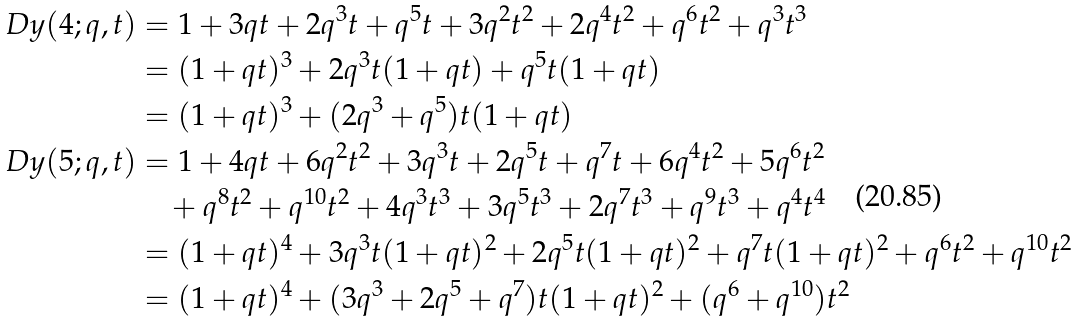<formula> <loc_0><loc_0><loc_500><loc_500>\ D y ( 4 ; q , t ) & = 1 + 3 q t + 2 q ^ { 3 } t + q ^ { 5 } t + 3 q ^ { 2 } t ^ { 2 } + 2 q ^ { 4 } t ^ { 2 } + q ^ { 6 } t ^ { 2 } + q ^ { 3 } t ^ { 3 } \\ & = ( 1 + q t ) ^ { 3 } + 2 q ^ { 3 } t ( 1 + q t ) + q ^ { 5 } t ( 1 + q t ) \\ & = ( 1 + q t ) ^ { 3 } + ( 2 q ^ { 3 } + q ^ { 5 } ) t ( 1 + q t ) \\ \ D y ( 5 ; q , t ) & = 1 + 4 q t + 6 q ^ { 2 } t ^ { 2 } + 3 q ^ { 3 } t + 2 q ^ { 5 } t + q ^ { 7 } t + 6 q ^ { 4 } t ^ { 2 } + 5 q ^ { 6 } t ^ { 2 } \\ & \quad + q ^ { 8 } t ^ { 2 } + q ^ { 1 0 } t ^ { 2 } + 4 q ^ { 3 } t ^ { 3 } + 3 q ^ { 5 } t ^ { 3 } + 2 q ^ { 7 } t ^ { 3 } + q ^ { 9 } t ^ { 3 } + q ^ { 4 } t ^ { 4 } \\ & = ( 1 + q t ) ^ { 4 } + 3 q ^ { 3 } t ( 1 + q t ) ^ { 2 } + 2 q ^ { 5 } t ( 1 + q t ) ^ { 2 } + q ^ { 7 } t ( 1 + q t ) ^ { 2 } + q ^ { 6 } t ^ { 2 } + q ^ { 1 0 } t ^ { 2 } \\ & = ( 1 + q t ) ^ { 4 } + ( 3 q ^ { 3 } + 2 q ^ { 5 } + q ^ { 7 } ) t ( 1 + q t ) ^ { 2 } + ( q ^ { 6 } + q ^ { 1 0 } ) t ^ { 2 }</formula> 